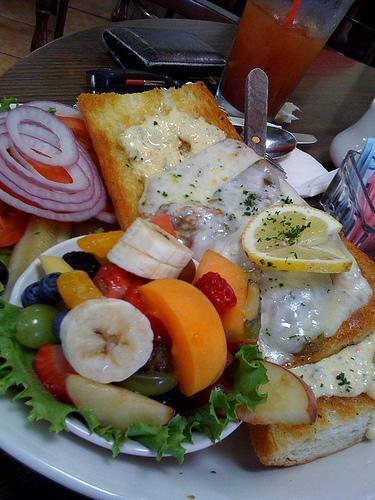How many spoons are there?
Give a very brief answer. 1. How many apples are in the photo?
Give a very brief answer. 2. 